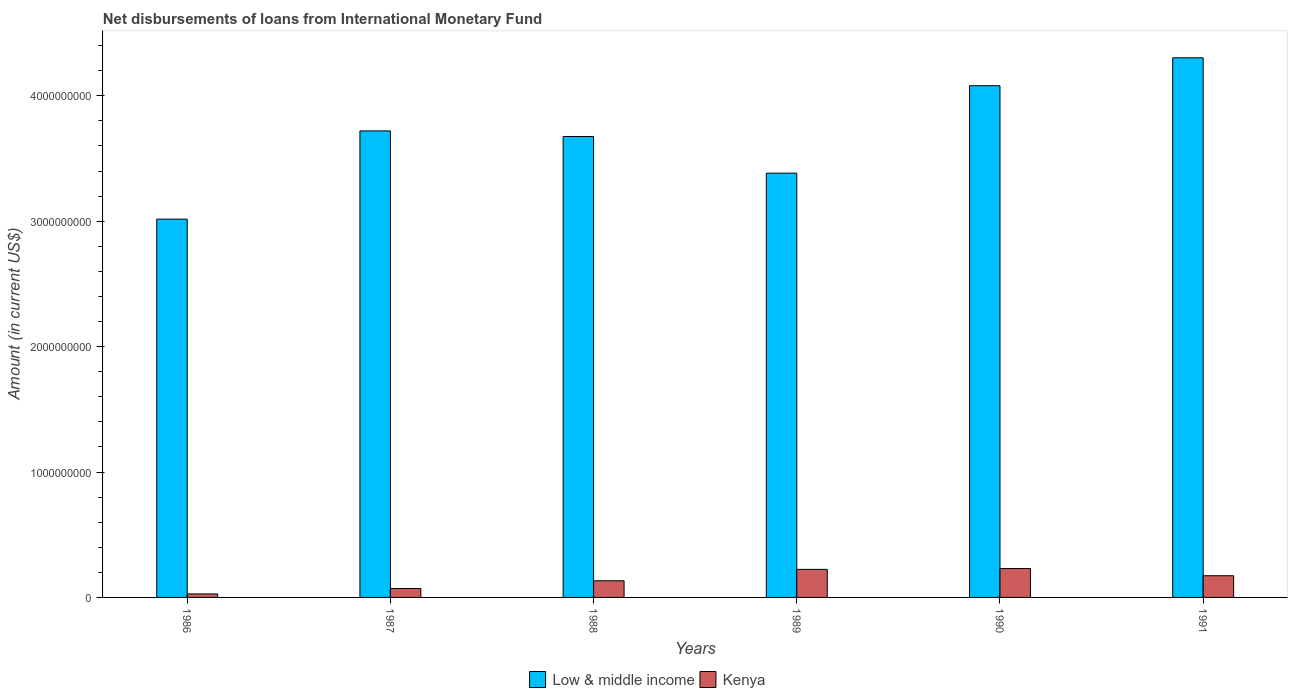How many bars are there on the 6th tick from the left?
Offer a very short reply. 2. In how many cases, is the number of bars for a given year not equal to the number of legend labels?
Give a very brief answer. 0. What is the amount of loans disbursed in Low & middle income in 1987?
Offer a terse response. 3.72e+09. Across all years, what is the maximum amount of loans disbursed in Kenya?
Provide a short and direct response. 2.30e+08. Across all years, what is the minimum amount of loans disbursed in Kenya?
Offer a very short reply. 2.80e+07. In which year was the amount of loans disbursed in Low & middle income maximum?
Ensure brevity in your answer.  1991. In which year was the amount of loans disbursed in Low & middle income minimum?
Offer a terse response. 1986. What is the total amount of loans disbursed in Low & middle income in the graph?
Your response must be concise. 2.22e+1. What is the difference between the amount of loans disbursed in Kenya in 1987 and that in 1991?
Your answer should be very brief. -1.02e+08. What is the difference between the amount of loans disbursed in Kenya in 1986 and the amount of loans disbursed in Low & middle income in 1990?
Offer a terse response. -4.05e+09. What is the average amount of loans disbursed in Kenya per year?
Offer a terse response. 1.43e+08. In the year 1991, what is the difference between the amount of loans disbursed in Kenya and amount of loans disbursed in Low & middle income?
Ensure brevity in your answer.  -4.13e+09. In how many years, is the amount of loans disbursed in Low & middle income greater than 3000000000 US$?
Make the answer very short. 6. What is the ratio of the amount of loans disbursed in Low & middle income in 1988 to that in 1991?
Provide a succinct answer. 0.85. Is the amount of loans disbursed in Kenya in 1986 less than that in 1989?
Your answer should be very brief. Yes. Is the difference between the amount of loans disbursed in Kenya in 1986 and 1988 greater than the difference between the amount of loans disbursed in Low & middle income in 1986 and 1988?
Give a very brief answer. Yes. What is the difference between the highest and the second highest amount of loans disbursed in Low & middle income?
Ensure brevity in your answer.  2.23e+08. What is the difference between the highest and the lowest amount of loans disbursed in Low & middle income?
Make the answer very short. 1.29e+09. What does the 2nd bar from the left in 1986 represents?
Keep it short and to the point. Kenya. What does the 1st bar from the right in 1990 represents?
Keep it short and to the point. Kenya. How many bars are there?
Your response must be concise. 12. What is the difference between two consecutive major ticks on the Y-axis?
Offer a terse response. 1.00e+09. Are the values on the major ticks of Y-axis written in scientific E-notation?
Offer a terse response. No. Does the graph contain any zero values?
Ensure brevity in your answer.  No. Does the graph contain grids?
Give a very brief answer. No. What is the title of the graph?
Your answer should be compact. Net disbursements of loans from International Monetary Fund. Does "Ecuador" appear as one of the legend labels in the graph?
Provide a short and direct response. No. What is the label or title of the X-axis?
Provide a short and direct response. Years. What is the label or title of the Y-axis?
Give a very brief answer. Amount (in current US$). What is the Amount (in current US$) of Low & middle income in 1986?
Your answer should be compact. 3.02e+09. What is the Amount (in current US$) in Kenya in 1986?
Offer a very short reply. 2.80e+07. What is the Amount (in current US$) of Low & middle income in 1987?
Your answer should be compact. 3.72e+09. What is the Amount (in current US$) in Kenya in 1987?
Provide a short and direct response. 7.11e+07. What is the Amount (in current US$) in Low & middle income in 1988?
Your answer should be very brief. 3.67e+09. What is the Amount (in current US$) in Kenya in 1988?
Give a very brief answer. 1.33e+08. What is the Amount (in current US$) of Low & middle income in 1989?
Give a very brief answer. 3.38e+09. What is the Amount (in current US$) in Kenya in 1989?
Give a very brief answer. 2.24e+08. What is the Amount (in current US$) in Low & middle income in 1990?
Give a very brief answer. 4.08e+09. What is the Amount (in current US$) of Kenya in 1990?
Provide a short and direct response. 2.30e+08. What is the Amount (in current US$) of Low & middle income in 1991?
Ensure brevity in your answer.  4.30e+09. What is the Amount (in current US$) of Kenya in 1991?
Your response must be concise. 1.73e+08. Across all years, what is the maximum Amount (in current US$) in Low & middle income?
Offer a terse response. 4.30e+09. Across all years, what is the maximum Amount (in current US$) in Kenya?
Provide a short and direct response. 2.30e+08. Across all years, what is the minimum Amount (in current US$) of Low & middle income?
Ensure brevity in your answer.  3.02e+09. Across all years, what is the minimum Amount (in current US$) of Kenya?
Give a very brief answer. 2.80e+07. What is the total Amount (in current US$) in Low & middle income in the graph?
Keep it short and to the point. 2.22e+1. What is the total Amount (in current US$) in Kenya in the graph?
Your response must be concise. 8.59e+08. What is the difference between the Amount (in current US$) in Low & middle income in 1986 and that in 1987?
Offer a very short reply. -7.03e+08. What is the difference between the Amount (in current US$) of Kenya in 1986 and that in 1987?
Ensure brevity in your answer.  -4.31e+07. What is the difference between the Amount (in current US$) of Low & middle income in 1986 and that in 1988?
Give a very brief answer. -6.58e+08. What is the difference between the Amount (in current US$) of Kenya in 1986 and that in 1988?
Keep it short and to the point. -1.05e+08. What is the difference between the Amount (in current US$) of Low & middle income in 1986 and that in 1989?
Offer a terse response. -3.67e+08. What is the difference between the Amount (in current US$) of Kenya in 1986 and that in 1989?
Your response must be concise. -1.96e+08. What is the difference between the Amount (in current US$) of Low & middle income in 1986 and that in 1990?
Your response must be concise. -1.06e+09. What is the difference between the Amount (in current US$) in Kenya in 1986 and that in 1990?
Offer a terse response. -2.02e+08. What is the difference between the Amount (in current US$) in Low & middle income in 1986 and that in 1991?
Ensure brevity in your answer.  -1.29e+09. What is the difference between the Amount (in current US$) of Kenya in 1986 and that in 1991?
Your response must be concise. -1.45e+08. What is the difference between the Amount (in current US$) of Low & middle income in 1987 and that in 1988?
Make the answer very short. 4.48e+07. What is the difference between the Amount (in current US$) of Kenya in 1987 and that in 1988?
Make the answer very short. -6.17e+07. What is the difference between the Amount (in current US$) in Low & middle income in 1987 and that in 1989?
Provide a succinct answer. 3.37e+08. What is the difference between the Amount (in current US$) of Kenya in 1987 and that in 1989?
Keep it short and to the point. -1.53e+08. What is the difference between the Amount (in current US$) in Low & middle income in 1987 and that in 1990?
Your answer should be very brief. -3.60e+08. What is the difference between the Amount (in current US$) in Kenya in 1987 and that in 1990?
Your answer should be compact. -1.59e+08. What is the difference between the Amount (in current US$) of Low & middle income in 1987 and that in 1991?
Your answer should be very brief. -5.83e+08. What is the difference between the Amount (in current US$) in Kenya in 1987 and that in 1991?
Make the answer very short. -1.02e+08. What is the difference between the Amount (in current US$) in Low & middle income in 1988 and that in 1989?
Keep it short and to the point. 2.92e+08. What is the difference between the Amount (in current US$) of Kenya in 1988 and that in 1989?
Give a very brief answer. -9.09e+07. What is the difference between the Amount (in current US$) in Low & middle income in 1988 and that in 1990?
Your answer should be compact. -4.05e+08. What is the difference between the Amount (in current US$) of Kenya in 1988 and that in 1990?
Provide a short and direct response. -9.76e+07. What is the difference between the Amount (in current US$) of Low & middle income in 1988 and that in 1991?
Make the answer very short. -6.28e+08. What is the difference between the Amount (in current US$) in Kenya in 1988 and that in 1991?
Your answer should be very brief. -4.02e+07. What is the difference between the Amount (in current US$) of Low & middle income in 1989 and that in 1990?
Provide a succinct answer. -6.97e+08. What is the difference between the Amount (in current US$) of Kenya in 1989 and that in 1990?
Provide a short and direct response. -6.73e+06. What is the difference between the Amount (in current US$) of Low & middle income in 1989 and that in 1991?
Keep it short and to the point. -9.20e+08. What is the difference between the Amount (in current US$) of Kenya in 1989 and that in 1991?
Your answer should be compact. 5.07e+07. What is the difference between the Amount (in current US$) in Low & middle income in 1990 and that in 1991?
Make the answer very short. -2.23e+08. What is the difference between the Amount (in current US$) of Kenya in 1990 and that in 1991?
Your response must be concise. 5.75e+07. What is the difference between the Amount (in current US$) in Low & middle income in 1986 and the Amount (in current US$) in Kenya in 1987?
Your answer should be very brief. 2.95e+09. What is the difference between the Amount (in current US$) in Low & middle income in 1986 and the Amount (in current US$) in Kenya in 1988?
Provide a short and direct response. 2.88e+09. What is the difference between the Amount (in current US$) in Low & middle income in 1986 and the Amount (in current US$) in Kenya in 1989?
Ensure brevity in your answer.  2.79e+09. What is the difference between the Amount (in current US$) of Low & middle income in 1986 and the Amount (in current US$) of Kenya in 1990?
Offer a very short reply. 2.79e+09. What is the difference between the Amount (in current US$) in Low & middle income in 1986 and the Amount (in current US$) in Kenya in 1991?
Ensure brevity in your answer.  2.84e+09. What is the difference between the Amount (in current US$) of Low & middle income in 1987 and the Amount (in current US$) of Kenya in 1988?
Offer a terse response. 3.59e+09. What is the difference between the Amount (in current US$) of Low & middle income in 1987 and the Amount (in current US$) of Kenya in 1989?
Offer a terse response. 3.50e+09. What is the difference between the Amount (in current US$) in Low & middle income in 1987 and the Amount (in current US$) in Kenya in 1990?
Offer a very short reply. 3.49e+09. What is the difference between the Amount (in current US$) of Low & middle income in 1987 and the Amount (in current US$) of Kenya in 1991?
Ensure brevity in your answer.  3.55e+09. What is the difference between the Amount (in current US$) in Low & middle income in 1988 and the Amount (in current US$) in Kenya in 1989?
Make the answer very short. 3.45e+09. What is the difference between the Amount (in current US$) in Low & middle income in 1988 and the Amount (in current US$) in Kenya in 1990?
Provide a succinct answer. 3.44e+09. What is the difference between the Amount (in current US$) of Low & middle income in 1988 and the Amount (in current US$) of Kenya in 1991?
Give a very brief answer. 3.50e+09. What is the difference between the Amount (in current US$) of Low & middle income in 1989 and the Amount (in current US$) of Kenya in 1990?
Offer a terse response. 3.15e+09. What is the difference between the Amount (in current US$) in Low & middle income in 1989 and the Amount (in current US$) in Kenya in 1991?
Provide a succinct answer. 3.21e+09. What is the difference between the Amount (in current US$) of Low & middle income in 1990 and the Amount (in current US$) of Kenya in 1991?
Offer a very short reply. 3.91e+09. What is the average Amount (in current US$) of Low & middle income per year?
Offer a terse response. 3.70e+09. What is the average Amount (in current US$) of Kenya per year?
Ensure brevity in your answer.  1.43e+08. In the year 1986, what is the difference between the Amount (in current US$) in Low & middle income and Amount (in current US$) in Kenya?
Ensure brevity in your answer.  2.99e+09. In the year 1987, what is the difference between the Amount (in current US$) in Low & middle income and Amount (in current US$) in Kenya?
Provide a succinct answer. 3.65e+09. In the year 1988, what is the difference between the Amount (in current US$) in Low & middle income and Amount (in current US$) in Kenya?
Your answer should be very brief. 3.54e+09. In the year 1989, what is the difference between the Amount (in current US$) of Low & middle income and Amount (in current US$) of Kenya?
Your answer should be compact. 3.16e+09. In the year 1990, what is the difference between the Amount (in current US$) in Low & middle income and Amount (in current US$) in Kenya?
Keep it short and to the point. 3.85e+09. In the year 1991, what is the difference between the Amount (in current US$) in Low & middle income and Amount (in current US$) in Kenya?
Offer a very short reply. 4.13e+09. What is the ratio of the Amount (in current US$) of Low & middle income in 1986 to that in 1987?
Ensure brevity in your answer.  0.81. What is the ratio of the Amount (in current US$) of Kenya in 1986 to that in 1987?
Ensure brevity in your answer.  0.39. What is the ratio of the Amount (in current US$) in Low & middle income in 1986 to that in 1988?
Keep it short and to the point. 0.82. What is the ratio of the Amount (in current US$) of Kenya in 1986 to that in 1988?
Give a very brief answer. 0.21. What is the ratio of the Amount (in current US$) in Low & middle income in 1986 to that in 1989?
Offer a very short reply. 0.89. What is the ratio of the Amount (in current US$) of Kenya in 1986 to that in 1989?
Make the answer very short. 0.13. What is the ratio of the Amount (in current US$) in Low & middle income in 1986 to that in 1990?
Your response must be concise. 0.74. What is the ratio of the Amount (in current US$) of Kenya in 1986 to that in 1990?
Provide a short and direct response. 0.12. What is the ratio of the Amount (in current US$) of Low & middle income in 1986 to that in 1991?
Provide a short and direct response. 0.7. What is the ratio of the Amount (in current US$) in Kenya in 1986 to that in 1991?
Give a very brief answer. 0.16. What is the ratio of the Amount (in current US$) of Low & middle income in 1987 to that in 1988?
Offer a very short reply. 1.01. What is the ratio of the Amount (in current US$) in Kenya in 1987 to that in 1988?
Provide a short and direct response. 0.54. What is the ratio of the Amount (in current US$) of Low & middle income in 1987 to that in 1989?
Ensure brevity in your answer.  1.1. What is the ratio of the Amount (in current US$) in Kenya in 1987 to that in 1989?
Provide a short and direct response. 0.32. What is the ratio of the Amount (in current US$) in Low & middle income in 1987 to that in 1990?
Offer a terse response. 0.91. What is the ratio of the Amount (in current US$) in Kenya in 1987 to that in 1990?
Your answer should be compact. 0.31. What is the ratio of the Amount (in current US$) of Low & middle income in 1987 to that in 1991?
Ensure brevity in your answer.  0.86. What is the ratio of the Amount (in current US$) of Kenya in 1987 to that in 1991?
Provide a succinct answer. 0.41. What is the ratio of the Amount (in current US$) in Low & middle income in 1988 to that in 1989?
Your answer should be compact. 1.09. What is the ratio of the Amount (in current US$) in Kenya in 1988 to that in 1989?
Provide a short and direct response. 0.59. What is the ratio of the Amount (in current US$) in Low & middle income in 1988 to that in 1990?
Provide a short and direct response. 0.9. What is the ratio of the Amount (in current US$) of Kenya in 1988 to that in 1990?
Offer a terse response. 0.58. What is the ratio of the Amount (in current US$) in Low & middle income in 1988 to that in 1991?
Keep it short and to the point. 0.85. What is the ratio of the Amount (in current US$) in Kenya in 1988 to that in 1991?
Offer a very short reply. 0.77. What is the ratio of the Amount (in current US$) of Low & middle income in 1989 to that in 1990?
Ensure brevity in your answer.  0.83. What is the ratio of the Amount (in current US$) of Kenya in 1989 to that in 1990?
Your answer should be very brief. 0.97. What is the ratio of the Amount (in current US$) in Low & middle income in 1989 to that in 1991?
Give a very brief answer. 0.79. What is the ratio of the Amount (in current US$) in Kenya in 1989 to that in 1991?
Give a very brief answer. 1.29. What is the ratio of the Amount (in current US$) of Low & middle income in 1990 to that in 1991?
Give a very brief answer. 0.95. What is the ratio of the Amount (in current US$) of Kenya in 1990 to that in 1991?
Provide a short and direct response. 1.33. What is the difference between the highest and the second highest Amount (in current US$) in Low & middle income?
Keep it short and to the point. 2.23e+08. What is the difference between the highest and the second highest Amount (in current US$) in Kenya?
Provide a succinct answer. 6.73e+06. What is the difference between the highest and the lowest Amount (in current US$) in Low & middle income?
Ensure brevity in your answer.  1.29e+09. What is the difference between the highest and the lowest Amount (in current US$) in Kenya?
Provide a short and direct response. 2.02e+08. 